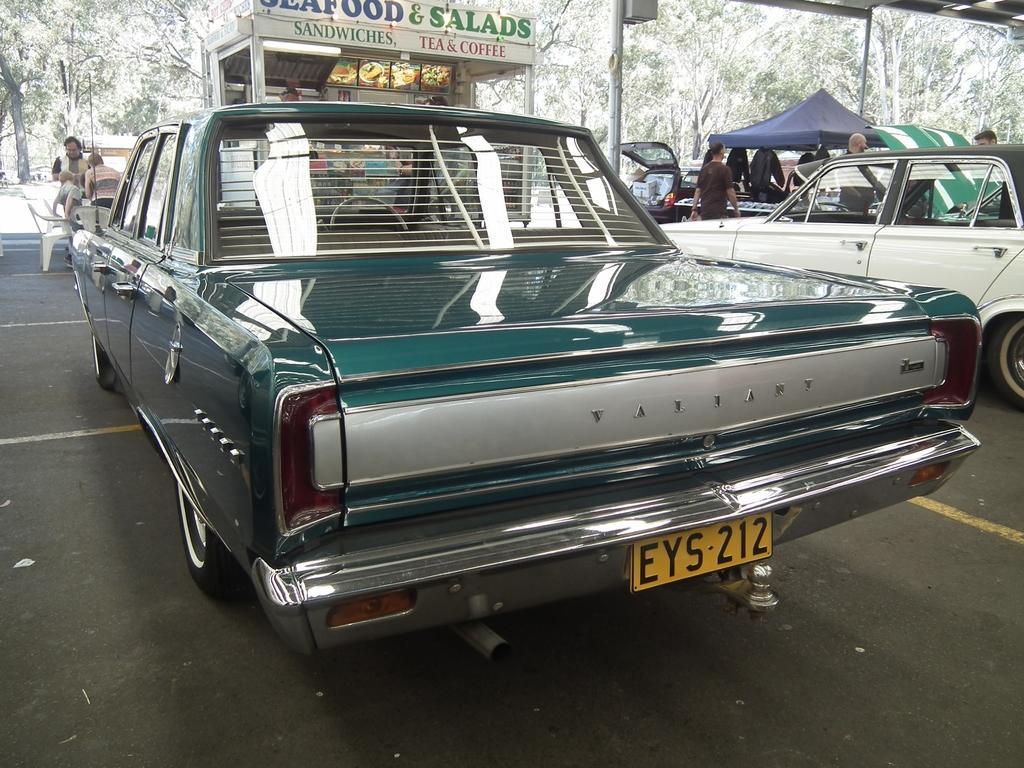Please provide a concise description of this image. In this image there are few vehicles, few people, chairs, trees, a shop and a tent. 